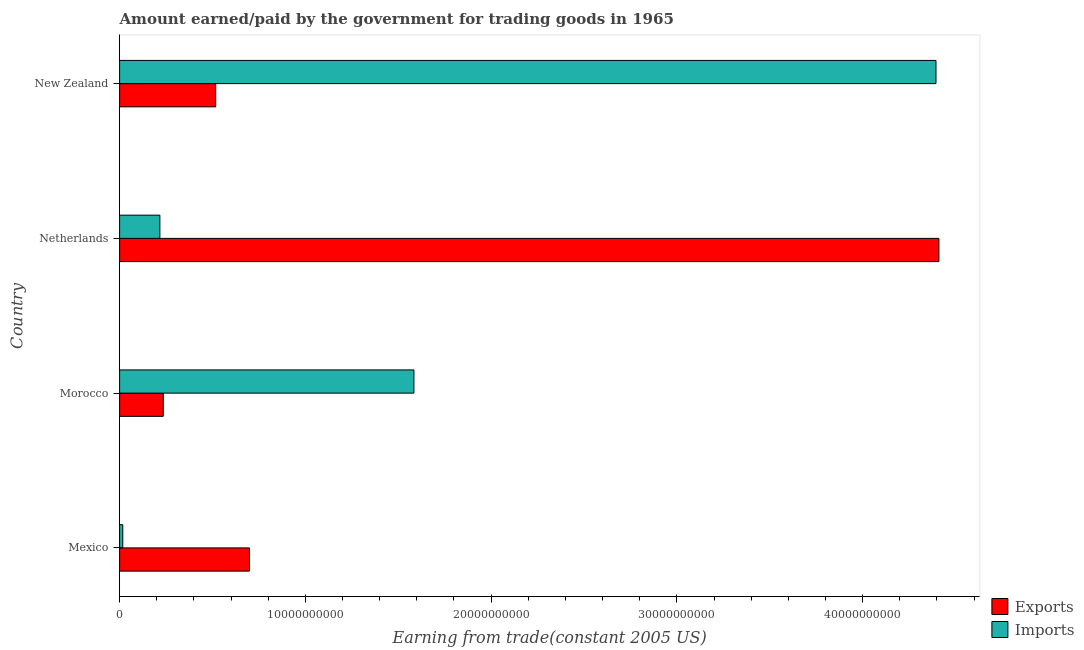Are the number of bars on each tick of the Y-axis equal?
Offer a very short reply. Yes. How many bars are there on the 3rd tick from the bottom?
Offer a terse response. 2. What is the amount paid for imports in Netherlands?
Make the answer very short. 2.17e+09. Across all countries, what is the maximum amount earned from exports?
Your response must be concise. 4.41e+1. Across all countries, what is the minimum amount earned from exports?
Provide a succinct answer. 2.35e+09. In which country was the amount paid for imports maximum?
Ensure brevity in your answer.  New Zealand. What is the total amount paid for imports in the graph?
Provide a short and direct response. 6.21e+1. What is the difference between the amount earned from exports in Mexico and that in Netherlands?
Provide a short and direct response. -3.71e+1. What is the difference between the amount paid for imports in Mexico and the amount earned from exports in Morocco?
Your answer should be very brief. -2.18e+09. What is the average amount paid for imports per country?
Ensure brevity in your answer.  1.55e+1. What is the difference between the amount earned from exports and amount paid for imports in Mexico?
Provide a succinct answer. 6.82e+09. In how many countries, is the amount paid for imports greater than 6000000000 US$?
Your answer should be compact. 2. What is the ratio of the amount earned from exports in Morocco to that in Netherlands?
Offer a very short reply. 0.05. Is the amount earned from exports in Morocco less than that in Netherlands?
Provide a short and direct response. Yes. Is the difference between the amount paid for imports in Morocco and New Zealand greater than the difference between the amount earned from exports in Morocco and New Zealand?
Your answer should be compact. No. What is the difference between the highest and the second highest amount paid for imports?
Provide a short and direct response. 2.81e+1. What is the difference between the highest and the lowest amount paid for imports?
Your response must be concise. 4.38e+1. Is the sum of the amount earned from exports in Mexico and Netherlands greater than the maximum amount paid for imports across all countries?
Ensure brevity in your answer.  Yes. What does the 2nd bar from the top in Netherlands represents?
Your answer should be very brief. Exports. What does the 2nd bar from the bottom in New Zealand represents?
Provide a short and direct response. Imports. How many bars are there?
Your answer should be compact. 8. How many countries are there in the graph?
Provide a succinct answer. 4. Are the values on the major ticks of X-axis written in scientific E-notation?
Give a very brief answer. No. Does the graph contain any zero values?
Keep it short and to the point. No. Does the graph contain grids?
Ensure brevity in your answer.  No. Where does the legend appear in the graph?
Provide a short and direct response. Bottom right. How are the legend labels stacked?
Offer a terse response. Vertical. What is the title of the graph?
Give a very brief answer. Amount earned/paid by the government for trading goods in 1965. What is the label or title of the X-axis?
Keep it short and to the point. Earning from trade(constant 2005 US). What is the Earning from trade(constant 2005 US) in Exports in Mexico?
Provide a succinct answer. 6.99e+09. What is the Earning from trade(constant 2005 US) of Imports in Mexico?
Ensure brevity in your answer.  1.71e+08. What is the Earning from trade(constant 2005 US) of Exports in Morocco?
Your answer should be very brief. 2.35e+09. What is the Earning from trade(constant 2005 US) of Imports in Morocco?
Your answer should be very brief. 1.58e+1. What is the Earning from trade(constant 2005 US) in Exports in Netherlands?
Offer a terse response. 4.41e+1. What is the Earning from trade(constant 2005 US) of Imports in Netherlands?
Offer a terse response. 2.17e+09. What is the Earning from trade(constant 2005 US) in Exports in New Zealand?
Your response must be concise. 5.17e+09. What is the Earning from trade(constant 2005 US) of Imports in New Zealand?
Provide a succinct answer. 4.39e+1. Across all countries, what is the maximum Earning from trade(constant 2005 US) in Exports?
Offer a very short reply. 4.41e+1. Across all countries, what is the maximum Earning from trade(constant 2005 US) in Imports?
Provide a short and direct response. 4.39e+1. Across all countries, what is the minimum Earning from trade(constant 2005 US) in Exports?
Offer a very short reply. 2.35e+09. Across all countries, what is the minimum Earning from trade(constant 2005 US) in Imports?
Make the answer very short. 1.71e+08. What is the total Earning from trade(constant 2005 US) in Exports in the graph?
Make the answer very short. 5.86e+1. What is the total Earning from trade(constant 2005 US) of Imports in the graph?
Ensure brevity in your answer.  6.21e+1. What is the difference between the Earning from trade(constant 2005 US) of Exports in Mexico and that in Morocco?
Provide a succinct answer. 4.64e+09. What is the difference between the Earning from trade(constant 2005 US) in Imports in Mexico and that in Morocco?
Your answer should be compact. -1.57e+1. What is the difference between the Earning from trade(constant 2005 US) in Exports in Mexico and that in Netherlands?
Ensure brevity in your answer.  -3.71e+1. What is the difference between the Earning from trade(constant 2005 US) of Imports in Mexico and that in Netherlands?
Your response must be concise. -2.00e+09. What is the difference between the Earning from trade(constant 2005 US) in Exports in Mexico and that in New Zealand?
Keep it short and to the point. 1.82e+09. What is the difference between the Earning from trade(constant 2005 US) of Imports in Mexico and that in New Zealand?
Provide a succinct answer. -4.38e+1. What is the difference between the Earning from trade(constant 2005 US) of Exports in Morocco and that in Netherlands?
Your answer should be very brief. -4.18e+1. What is the difference between the Earning from trade(constant 2005 US) of Imports in Morocco and that in Netherlands?
Ensure brevity in your answer.  1.37e+1. What is the difference between the Earning from trade(constant 2005 US) of Exports in Morocco and that in New Zealand?
Provide a succinct answer. -2.82e+09. What is the difference between the Earning from trade(constant 2005 US) of Imports in Morocco and that in New Zealand?
Provide a succinct answer. -2.81e+1. What is the difference between the Earning from trade(constant 2005 US) in Exports in Netherlands and that in New Zealand?
Provide a succinct answer. 3.89e+1. What is the difference between the Earning from trade(constant 2005 US) of Imports in Netherlands and that in New Zealand?
Ensure brevity in your answer.  -4.18e+1. What is the difference between the Earning from trade(constant 2005 US) of Exports in Mexico and the Earning from trade(constant 2005 US) of Imports in Morocco?
Provide a succinct answer. -8.85e+09. What is the difference between the Earning from trade(constant 2005 US) in Exports in Mexico and the Earning from trade(constant 2005 US) in Imports in Netherlands?
Provide a succinct answer. 4.82e+09. What is the difference between the Earning from trade(constant 2005 US) of Exports in Mexico and the Earning from trade(constant 2005 US) of Imports in New Zealand?
Ensure brevity in your answer.  -3.70e+1. What is the difference between the Earning from trade(constant 2005 US) in Exports in Morocco and the Earning from trade(constant 2005 US) in Imports in Netherlands?
Offer a terse response. 1.81e+08. What is the difference between the Earning from trade(constant 2005 US) in Exports in Morocco and the Earning from trade(constant 2005 US) in Imports in New Zealand?
Keep it short and to the point. -4.16e+1. What is the difference between the Earning from trade(constant 2005 US) in Exports in Netherlands and the Earning from trade(constant 2005 US) in Imports in New Zealand?
Provide a short and direct response. 1.58e+08. What is the average Earning from trade(constant 2005 US) of Exports per country?
Your response must be concise. 1.47e+1. What is the average Earning from trade(constant 2005 US) in Imports per country?
Offer a terse response. 1.55e+1. What is the difference between the Earning from trade(constant 2005 US) in Exports and Earning from trade(constant 2005 US) in Imports in Mexico?
Give a very brief answer. 6.82e+09. What is the difference between the Earning from trade(constant 2005 US) of Exports and Earning from trade(constant 2005 US) of Imports in Morocco?
Your response must be concise. -1.35e+1. What is the difference between the Earning from trade(constant 2005 US) in Exports and Earning from trade(constant 2005 US) in Imports in Netherlands?
Offer a terse response. 4.19e+1. What is the difference between the Earning from trade(constant 2005 US) of Exports and Earning from trade(constant 2005 US) of Imports in New Zealand?
Ensure brevity in your answer.  -3.88e+1. What is the ratio of the Earning from trade(constant 2005 US) in Exports in Mexico to that in Morocco?
Give a very brief answer. 2.98. What is the ratio of the Earning from trade(constant 2005 US) in Imports in Mexico to that in Morocco?
Keep it short and to the point. 0.01. What is the ratio of the Earning from trade(constant 2005 US) of Exports in Mexico to that in Netherlands?
Provide a succinct answer. 0.16. What is the ratio of the Earning from trade(constant 2005 US) in Imports in Mexico to that in Netherlands?
Keep it short and to the point. 0.08. What is the ratio of the Earning from trade(constant 2005 US) in Exports in Mexico to that in New Zealand?
Make the answer very short. 1.35. What is the ratio of the Earning from trade(constant 2005 US) in Imports in Mexico to that in New Zealand?
Ensure brevity in your answer.  0. What is the ratio of the Earning from trade(constant 2005 US) in Exports in Morocco to that in Netherlands?
Keep it short and to the point. 0.05. What is the ratio of the Earning from trade(constant 2005 US) of Imports in Morocco to that in Netherlands?
Your answer should be very brief. 7.31. What is the ratio of the Earning from trade(constant 2005 US) in Exports in Morocco to that in New Zealand?
Provide a succinct answer. 0.45. What is the ratio of the Earning from trade(constant 2005 US) of Imports in Morocco to that in New Zealand?
Make the answer very short. 0.36. What is the ratio of the Earning from trade(constant 2005 US) of Exports in Netherlands to that in New Zealand?
Offer a very short reply. 8.53. What is the ratio of the Earning from trade(constant 2005 US) in Imports in Netherlands to that in New Zealand?
Your answer should be very brief. 0.05. What is the difference between the highest and the second highest Earning from trade(constant 2005 US) of Exports?
Give a very brief answer. 3.71e+1. What is the difference between the highest and the second highest Earning from trade(constant 2005 US) in Imports?
Your answer should be compact. 2.81e+1. What is the difference between the highest and the lowest Earning from trade(constant 2005 US) in Exports?
Provide a short and direct response. 4.18e+1. What is the difference between the highest and the lowest Earning from trade(constant 2005 US) of Imports?
Ensure brevity in your answer.  4.38e+1. 